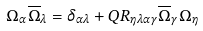<formula> <loc_0><loc_0><loc_500><loc_500>\Omega _ { \alpha } \overline { \Omega } _ { \lambda } = \delta _ { \alpha \lambda } + Q R _ { \eta \lambda \alpha \gamma } \overline { \Omega } _ { \gamma } \Omega _ { \eta }</formula> 